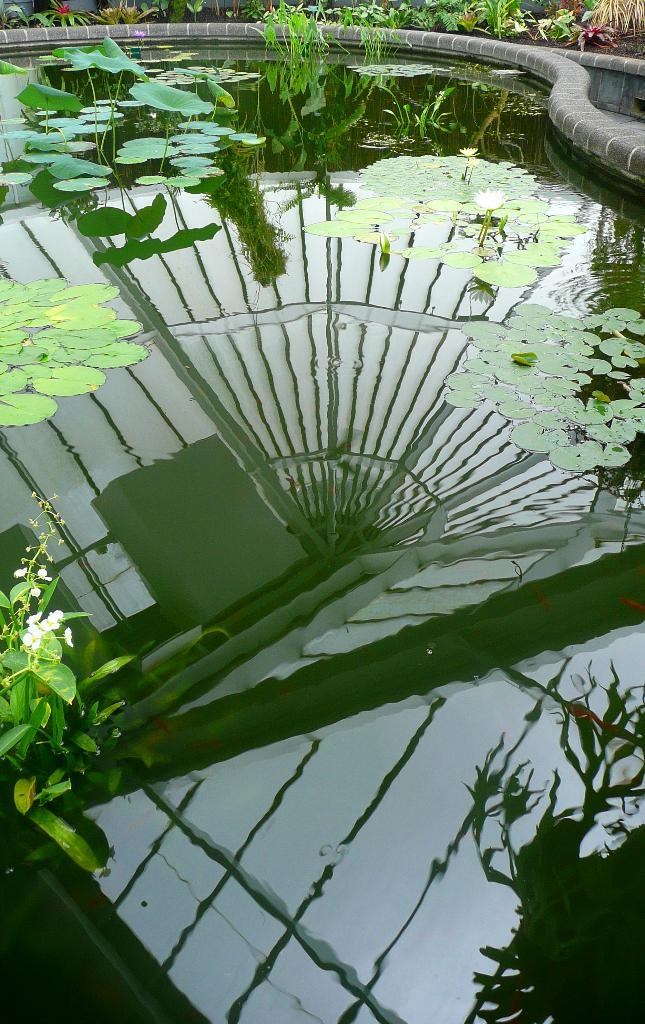What can be seen in the image? There is water visible in the image, and there are plants present as well. Can you describe the plants in the image? Unfortunately, the facts provided do not give enough detail to describe the plants in the image. What is the primary element in the image? The primary element in the image is water. What type of eggnog is being served in the image? There is no eggnog present in the image; it only features water and plants. Can you see any steam coming from the pot in the image? There is no pot or steam present in the image; it only features water and plants. 